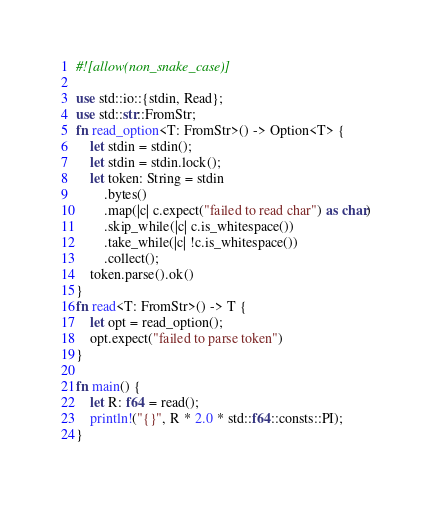<code> <loc_0><loc_0><loc_500><loc_500><_Rust_>#![allow(non_snake_case)]

use std::io::{stdin, Read};
use std::str::FromStr;
fn read_option<T: FromStr>() -> Option<T> {
    let stdin = stdin();
    let stdin = stdin.lock();
    let token: String = stdin
        .bytes()
        .map(|c| c.expect("failed to read char") as char)
        .skip_while(|c| c.is_whitespace())
        .take_while(|c| !c.is_whitespace())
        .collect();
    token.parse().ok()
}
fn read<T: FromStr>() -> T {
    let opt = read_option();
    opt.expect("failed to parse token")
}

fn main() {
    let R: f64 = read();
    println!("{}", R * 2.0 * std::f64::consts::PI);
}
</code> 